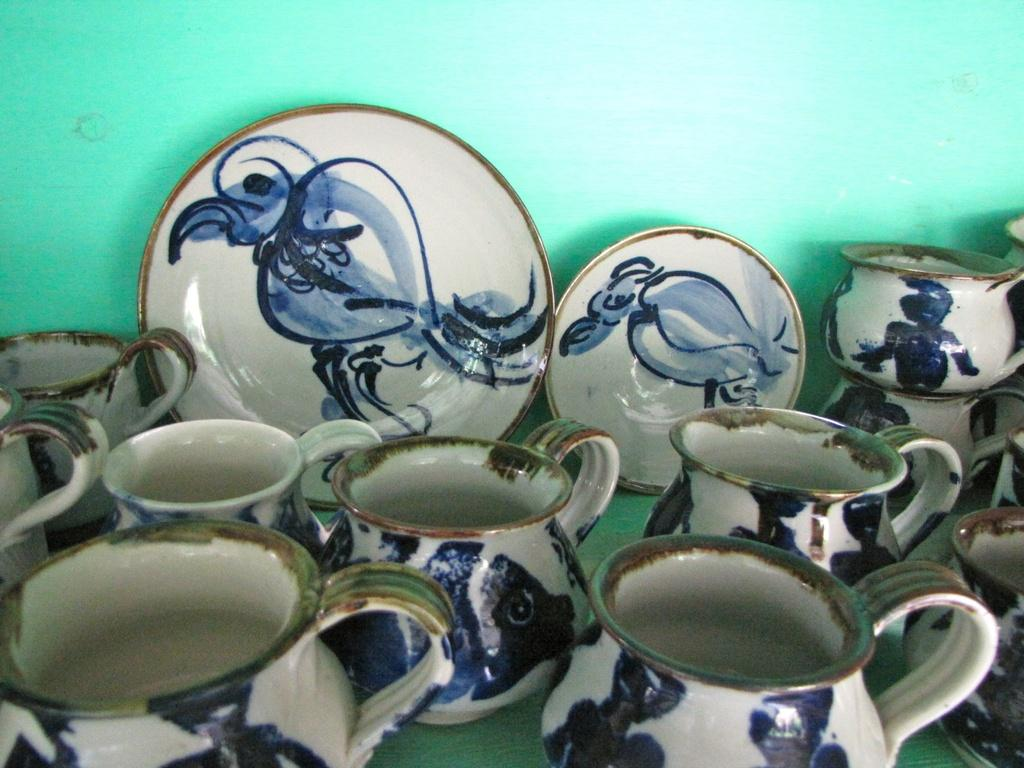What type of objects can be seen on the plates in the image? The provided facts do not specify what is on the plates. What are the jars used for in the image? The provided facts do not specify the purpose of the jars. What color is the wall in the image? The wall in the image is green. Can you see any giants playing in the field in the image? There is no field or giants present in the image. How long did the people in the image rest before continuing their activities? The provided facts do not mention any people or activities in the image. 